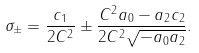Convert formula to latex. <formula><loc_0><loc_0><loc_500><loc_500>\sigma _ { \pm } = \frac { c _ { 1 } } { 2 C ^ { 2 } } \pm \frac { C ^ { 2 } a _ { 0 } - a _ { 2 } c _ { 2 } } { 2 C ^ { 2 } \sqrt { - a _ { 0 } a _ { 2 } } } .</formula> 